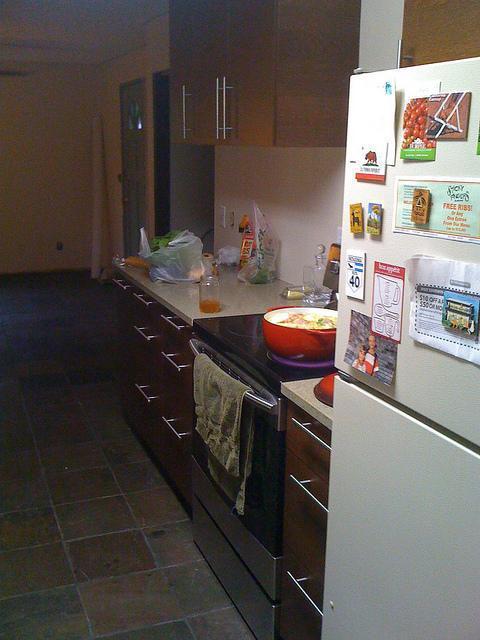How many ovens are there?
Give a very brief answer. 1. 